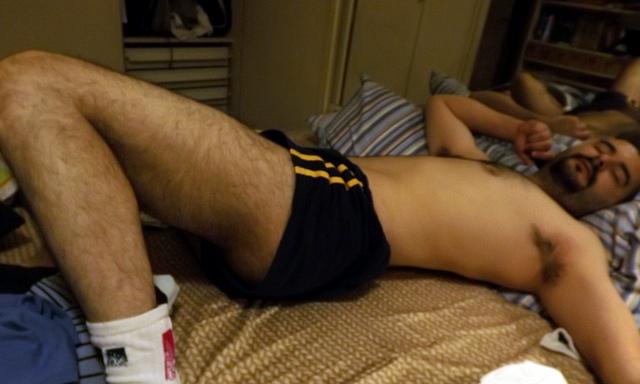What color are the socks?
Quick response, please. White. Is this man laying on a bed?
Concise answer only. Yes. Does he look cozy?
Concise answer only. Yes. What is the man lying on?
Give a very brief answer. Bed. What color are the man's shorts?
Be succinct. Black. 